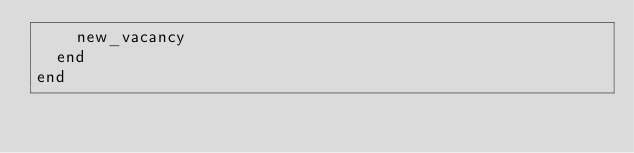Convert code to text. <code><loc_0><loc_0><loc_500><loc_500><_Ruby_>    new_vacancy
  end
end
</code> 